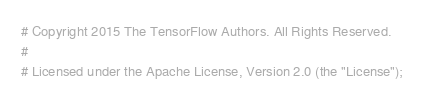Convert code to text. <code><loc_0><loc_0><loc_500><loc_500><_Python_># Copyright 2015 The TensorFlow Authors. All Rights Reserved.
#
# Licensed under the Apache License, Version 2.0 (the "License");</code> 